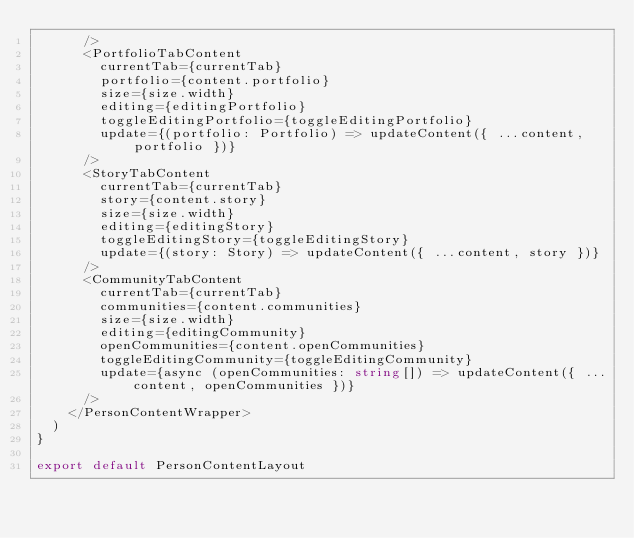Convert code to text. <code><loc_0><loc_0><loc_500><loc_500><_TypeScript_>      />
      <PortfolioTabContent
        currentTab={currentTab}
        portfolio={content.portfolio}
        size={size.width}
        editing={editingPortfolio}
        toggleEditingPortfolio={toggleEditingPortfolio}
        update={(portfolio: Portfolio) => updateContent({ ...content, portfolio })}
      />
      <StoryTabContent
        currentTab={currentTab}
        story={content.story}
        size={size.width}
        editing={editingStory}
        toggleEditingStory={toggleEditingStory}
        update={(story: Story) => updateContent({ ...content, story })}
      />
      <CommunityTabContent
        currentTab={currentTab}
        communities={content.communities}
        size={size.width}
        editing={editingCommunity}
        openCommunities={content.openCommunities}
        toggleEditingCommunity={toggleEditingCommunity}
        update={async (openCommunities: string[]) => updateContent({ ...content, openCommunities })}
      />
    </PersonContentWrapper>
  )
}

export default PersonContentLayout
</code> 